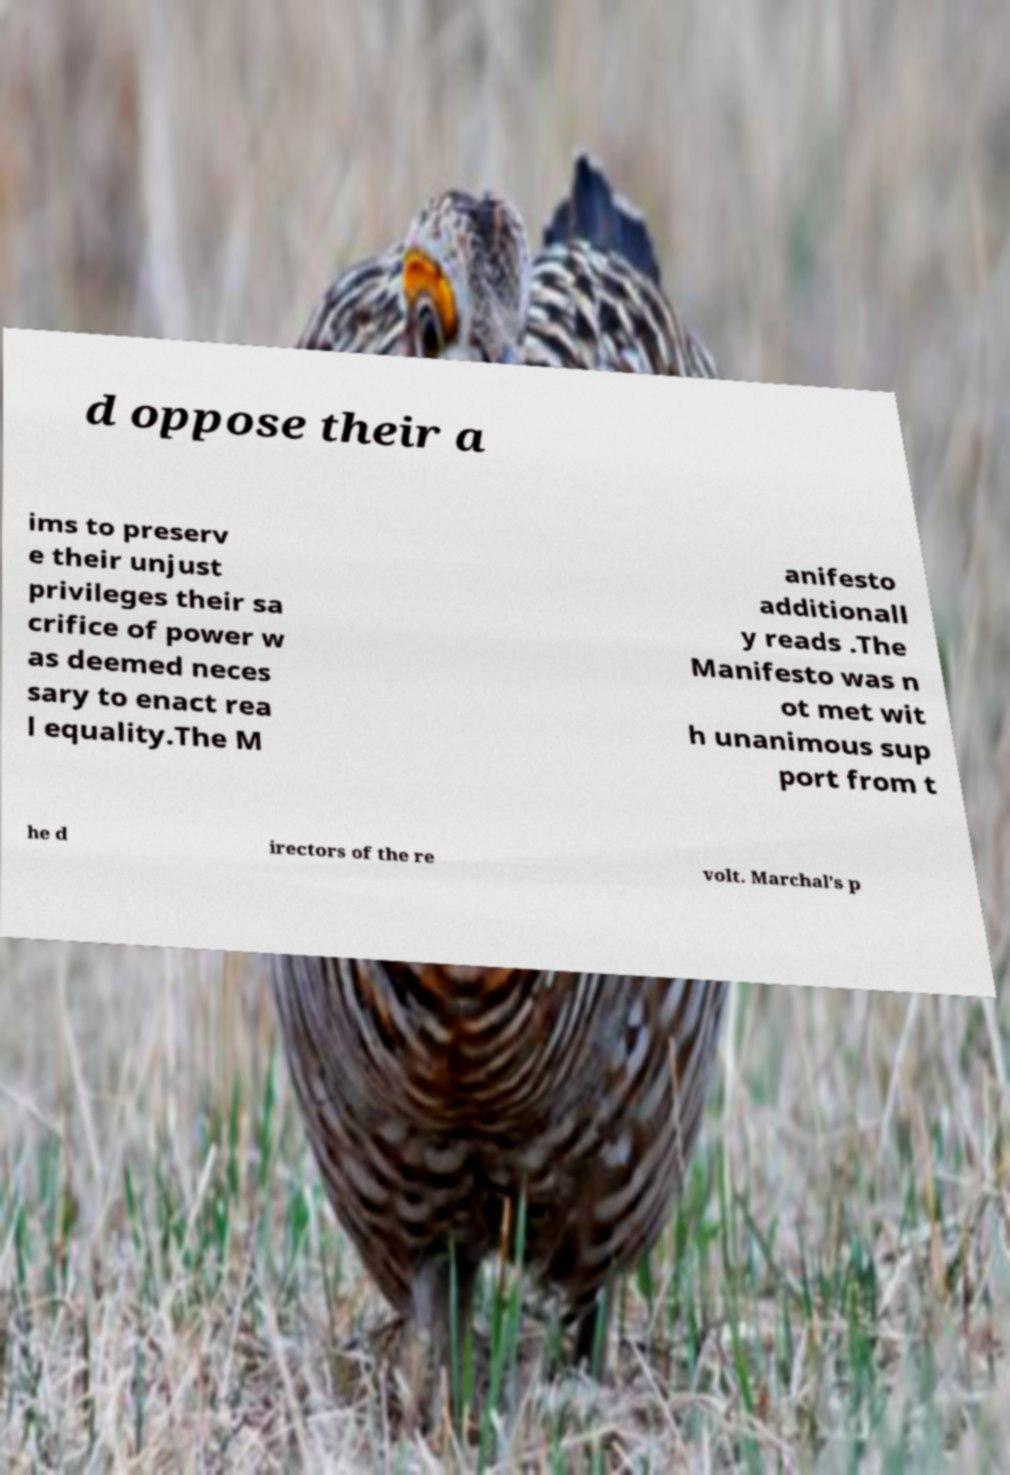I need the written content from this picture converted into text. Can you do that? d oppose their a ims to preserv e their unjust privileges their sa crifice of power w as deemed neces sary to enact rea l equality.The M anifesto additionall y reads .The Manifesto was n ot met wit h unanimous sup port from t he d irectors of the re volt. Marchal’s p 